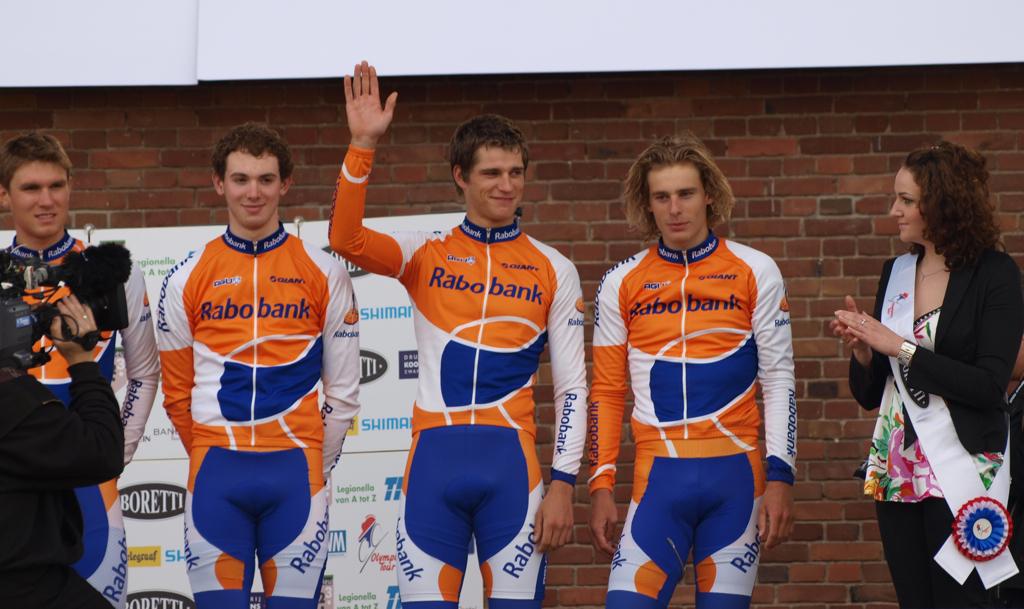Who is the sponsor on their uniforms?
Ensure brevity in your answer.  Rabobank. What is the name of one of the advertisements in the back of the players?
Provide a succinct answer. Boretti. 